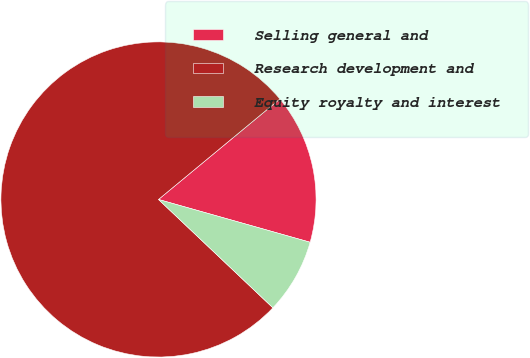Convert chart. <chart><loc_0><loc_0><loc_500><loc_500><pie_chart><fcel>Selling general and<fcel>Research development and<fcel>Equity royalty and interest<nl><fcel>15.38%<fcel>76.92%<fcel>7.69%<nl></chart> 